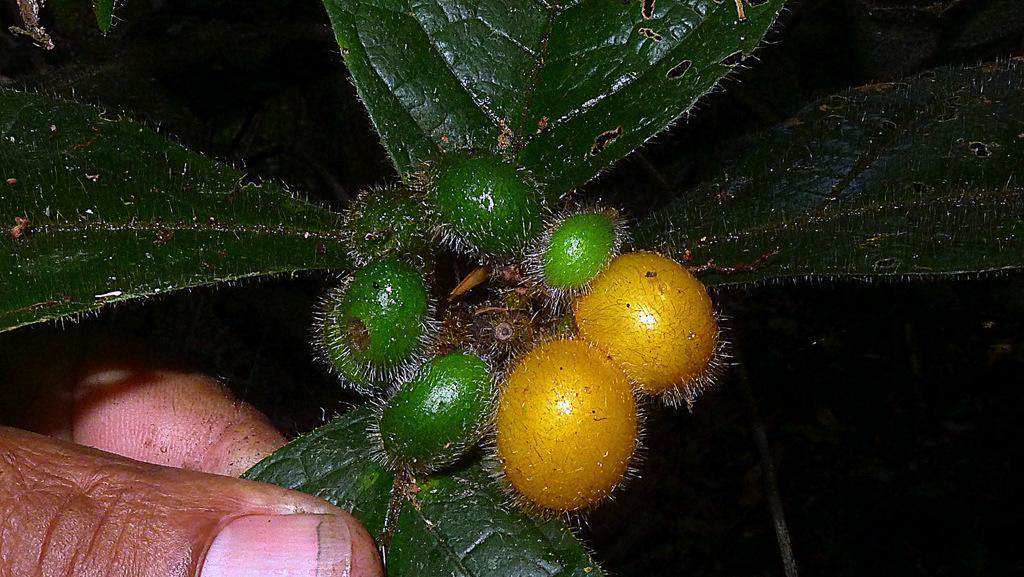What is the main subject of the image? There is a person in the image. What is the person holding in the image? The person is holding some leaves and some objects. What type of dress is the person wearing in the image? The provided facts do not mention any dress or clothing worn by the person in the image. Can you see a toothbrush in the person's hand in the image? There is no toothbrush mentioned or visible in the image. Is there any bread visible in the person's hand in the image? The provided facts do not mention any bread or food items in the image. 